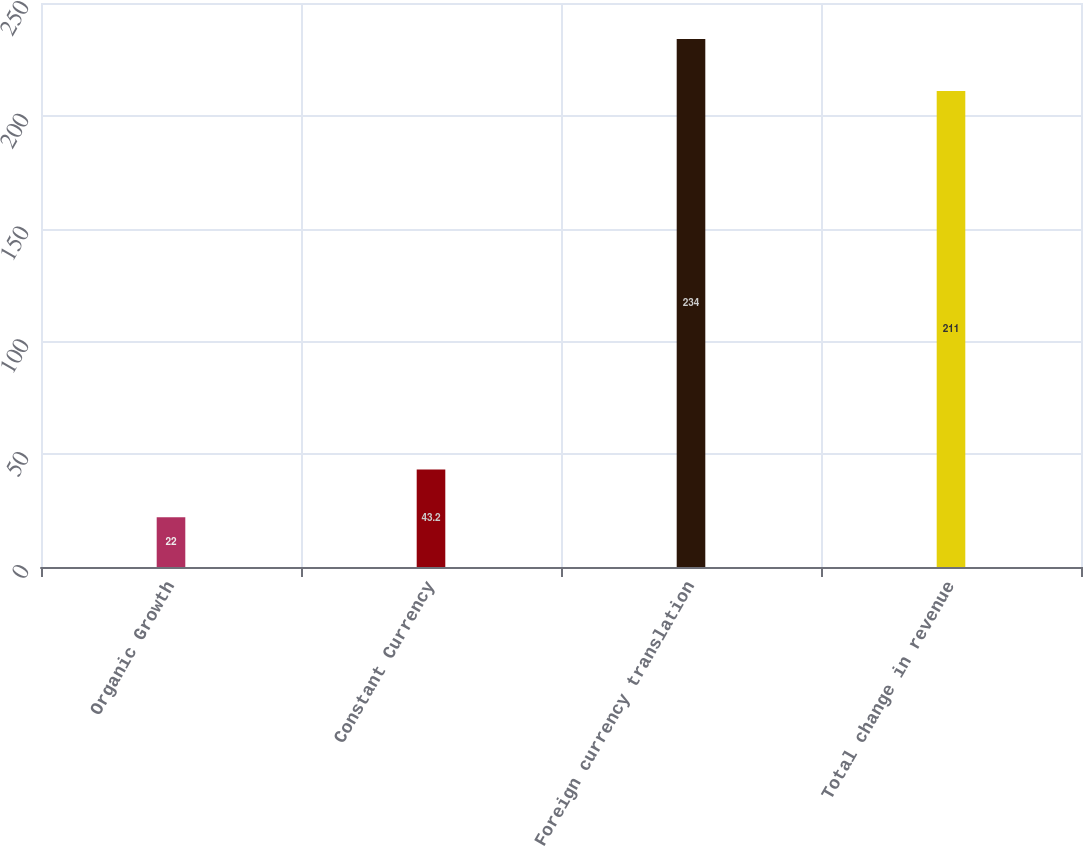Convert chart to OTSL. <chart><loc_0><loc_0><loc_500><loc_500><bar_chart><fcel>Organic Growth<fcel>Constant Currency<fcel>Foreign currency translation<fcel>Total change in revenue<nl><fcel>22<fcel>43.2<fcel>234<fcel>211<nl></chart> 